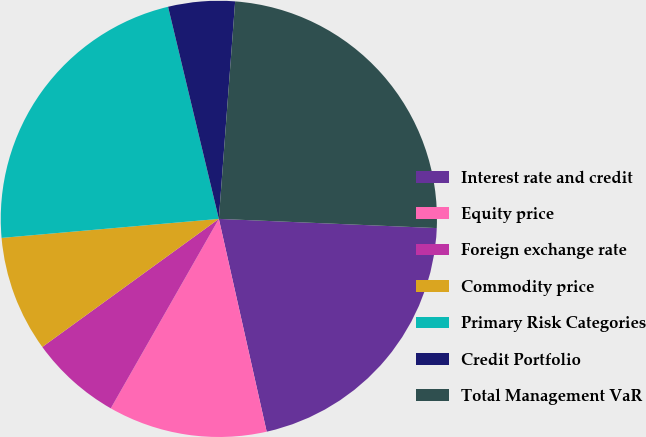Convert chart to OTSL. <chart><loc_0><loc_0><loc_500><loc_500><pie_chart><fcel>Interest rate and credit<fcel>Equity price<fcel>Foreign exchange rate<fcel>Commodity price<fcel>Primary Risk Categories<fcel>Credit Portfolio<fcel>Total Management VaR<nl><fcel>20.81%<fcel>11.77%<fcel>6.76%<fcel>8.6%<fcel>22.65%<fcel>4.93%<fcel>24.48%<nl></chart> 